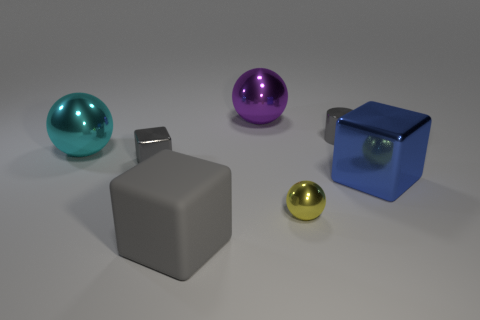Subtract all small gray metal blocks. How many blocks are left? 2 Subtract all blocks. How many objects are left? 4 Subtract 3 balls. How many balls are left? 0 Subtract all gray cubes. How many cubes are left? 1 Add 2 tiny blocks. How many objects exist? 9 Subtract 0 red balls. How many objects are left? 7 Subtract all green cylinders. Subtract all cyan spheres. How many cylinders are left? 1 Subtract all green cubes. How many yellow spheres are left? 1 Subtract all big purple spheres. Subtract all yellow metallic cylinders. How many objects are left? 6 Add 6 small gray shiny cylinders. How many small gray shiny cylinders are left? 7 